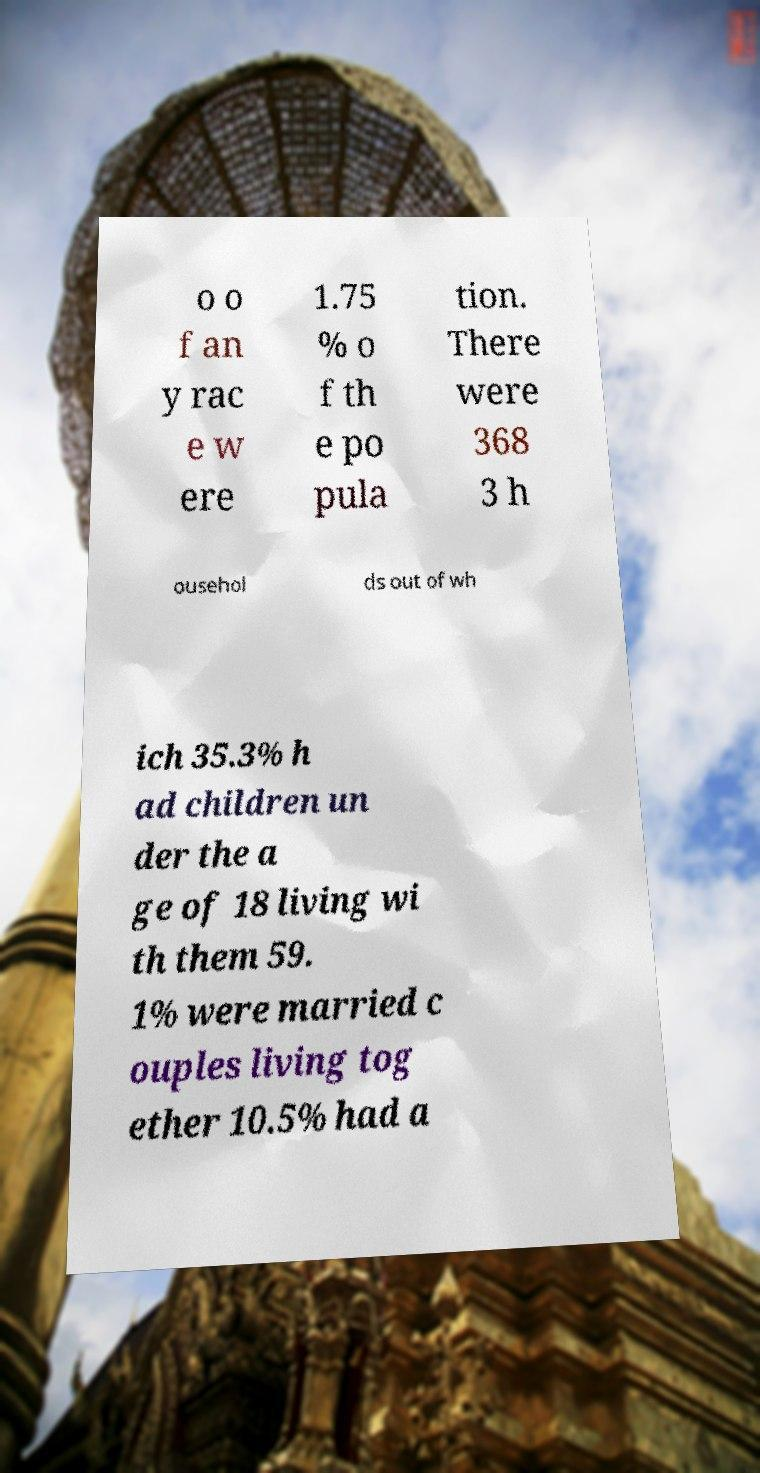Please identify and transcribe the text found in this image. o o f an y rac e w ere 1.75 % o f th e po pula tion. There were 368 3 h ousehol ds out of wh ich 35.3% h ad children un der the a ge of 18 living wi th them 59. 1% were married c ouples living tog ether 10.5% had a 